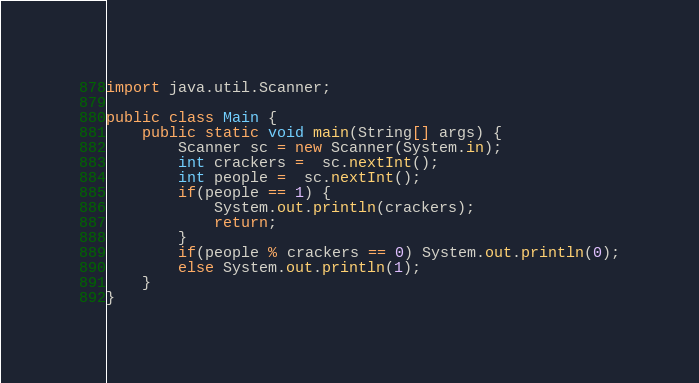<code> <loc_0><loc_0><loc_500><loc_500><_Java_>import java.util.Scanner;

public class Main {
    public static void main(String[] args) {
        Scanner sc = new Scanner(System.in);
        int crackers =  sc.nextInt();
        int people =  sc.nextInt();
        if(people == 1) {
            System.out.println(crackers);
            return;
        }
        if(people % crackers == 0) System.out.println(0);
        else System.out.println(1);
    }
}
</code> 